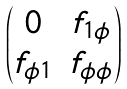<formula> <loc_0><loc_0><loc_500><loc_500>\begin{pmatrix} 0 & f _ { 1 \phi } \\ f _ { \phi 1 } & f _ { \phi \phi } \end{pmatrix}</formula> 